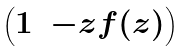<formula> <loc_0><loc_0><loc_500><loc_500>\begin{pmatrix} 1 & - z f ( z ) \end{pmatrix}</formula> 